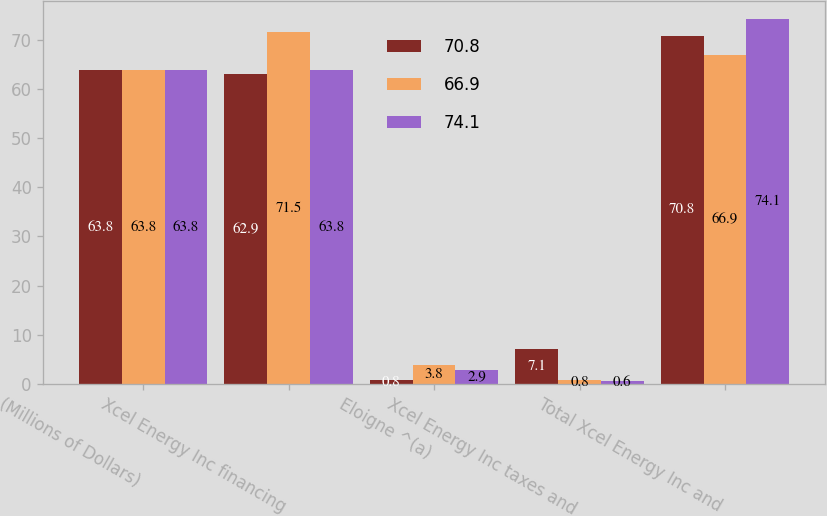Convert chart to OTSL. <chart><loc_0><loc_0><loc_500><loc_500><stacked_bar_chart><ecel><fcel>(Millions of Dollars)<fcel>Xcel Energy Inc financing<fcel>Eloigne ^(a)<fcel>Xcel Energy Inc taxes and<fcel>Total Xcel Energy Inc and<nl><fcel>70.8<fcel>63.8<fcel>62.9<fcel>0.8<fcel>7.1<fcel>70.8<nl><fcel>66.9<fcel>63.8<fcel>71.5<fcel>3.8<fcel>0.8<fcel>66.9<nl><fcel>74.1<fcel>63.8<fcel>63.8<fcel>2.9<fcel>0.6<fcel>74.1<nl></chart> 